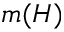<formula> <loc_0><loc_0><loc_500><loc_500>m ( H )</formula> 